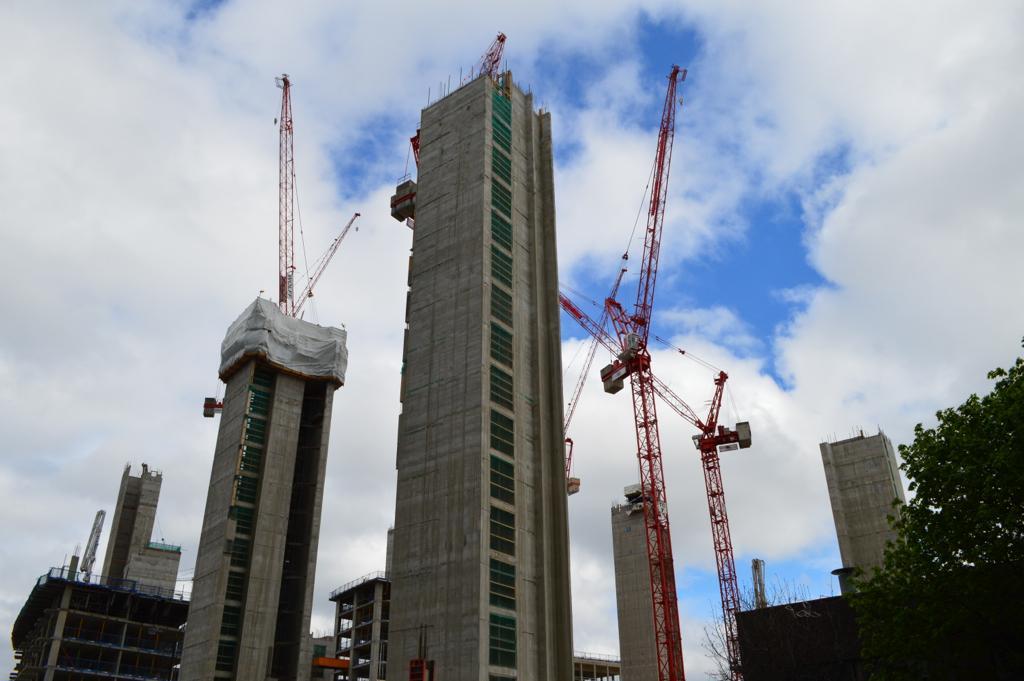Describe this image in one or two sentences. In this image I can see a tree, few buildings which are ash in color and few cranes which are orange in color. In the background I can see the sky. 